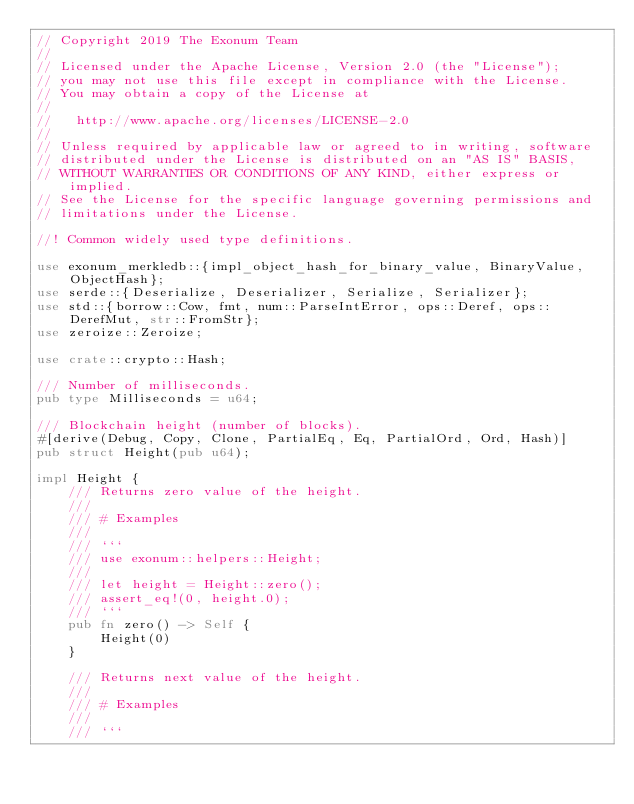Convert code to text. <code><loc_0><loc_0><loc_500><loc_500><_Rust_>// Copyright 2019 The Exonum Team
//
// Licensed under the Apache License, Version 2.0 (the "License");
// you may not use this file except in compliance with the License.
// You may obtain a copy of the License at
//
//   http://www.apache.org/licenses/LICENSE-2.0
//
// Unless required by applicable law or agreed to in writing, software
// distributed under the License is distributed on an "AS IS" BASIS,
// WITHOUT WARRANTIES OR CONDITIONS OF ANY KIND, either express or implied.
// See the License for the specific language governing permissions and
// limitations under the License.

//! Common widely used type definitions.

use exonum_merkledb::{impl_object_hash_for_binary_value, BinaryValue, ObjectHash};
use serde::{Deserialize, Deserializer, Serialize, Serializer};
use std::{borrow::Cow, fmt, num::ParseIntError, ops::Deref, ops::DerefMut, str::FromStr};
use zeroize::Zeroize;

use crate::crypto::Hash;

/// Number of milliseconds.
pub type Milliseconds = u64;

/// Blockchain height (number of blocks).
#[derive(Debug, Copy, Clone, PartialEq, Eq, PartialOrd, Ord, Hash)]
pub struct Height(pub u64);

impl Height {
    /// Returns zero value of the height.
    ///
    /// # Examples
    ///
    /// ```
    /// use exonum::helpers::Height;
    ///
    /// let height = Height::zero();
    /// assert_eq!(0, height.0);
    /// ```
    pub fn zero() -> Self {
        Height(0)
    }

    /// Returns next value of the height.
    ///
    /// # Examples
    ///
    /// ```</code> 